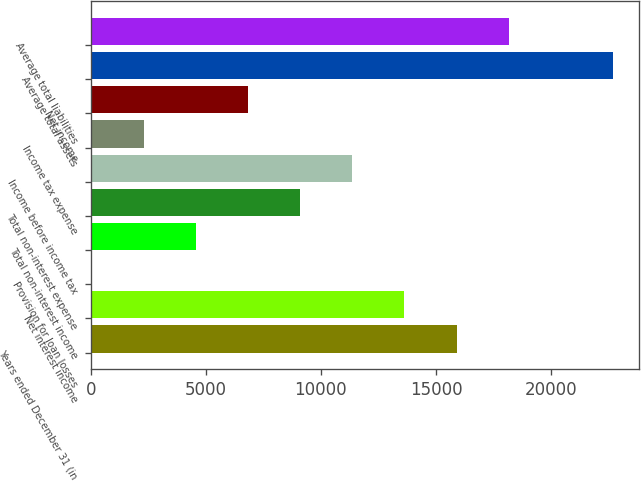Convert chart to OTSL. <chart><loc_0><loc_0><loc_500><loc_500><bar_chart><fcel>Years ended December 31 (in<fcel>Net interest income<fcel>Provision for loan losses<fcel>Total non-interest income<fcel>Total non-interest expense<fcel>Income before income tax<fcel>Income tax expense<fcel>Net income<fcel>Average total assets<fcel>Average total liabilities<nl><fcel>15895.6<fcel>13630.4<fcel>39.3<fcel>4569.66<fcel>9100.02<fcel>11365.2<fcel>2304.48<fcel>6834.84<fcel>22691.1<fcel>18160.7<nl></chart> 